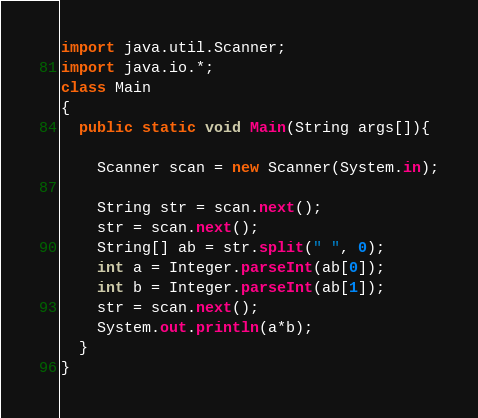<code> <loc_0><loc_0><loc_500><loc_500><_Java_>import java.util.Scanner;
import java.io.*;
class Main
{
  public static void Main(String args[]){
    
    Scanner scan = new Scanner(System.in);

    String str = scan.next();
	str = scan.next();
    String[] ab = str.split(" ", 0);
	int a = Integer.parseInt(ab[0]);
	int b = Integer.parseInt(ab[1]);
    str = scan.next();
    System.out.println(a*b);
  }
}</code> 